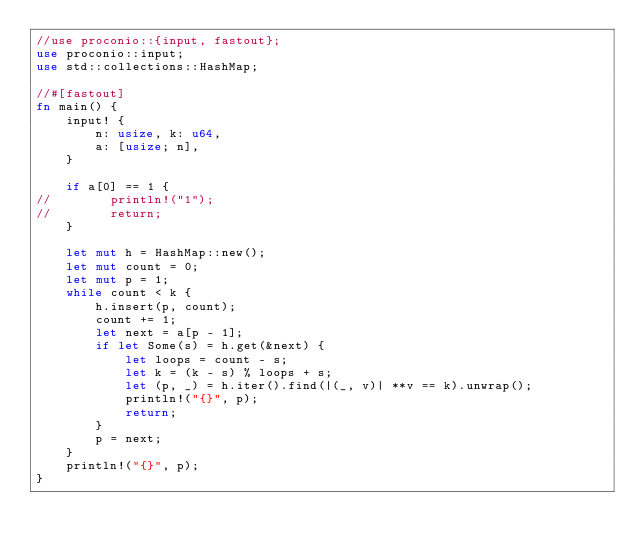Convert code to text. <code><loc_0><loc_0><loc_500><loc_500><_Rust_>//use proconio::{input, fastout};
use proconio::input;
use std::collections::HashMap;

//#[fastout]
fn main() {
    input! {
        n: usize, k: u64,
        a: [usize; n],
    }

    if a[0] == 1 {
//        println!("1");
//        return;
    }

    let mut h = HashMap::new();
    let mut count = 0;
    let mut p = 1;
    while count < k {
        h.insert(p, count);
        count += 1;
        let next = a[p - 1];
        if let Some(s) = h.get(&next) {
            let loops = count - s;
            let k = (k - s) % loops + s;
            let (p, _) = h.iter().find(|(_, v)| **v == k).unwrap();
            println!("{}", p);
            return;
        }
        p = next;
    }
    println!("{}", p);
}
</code> 